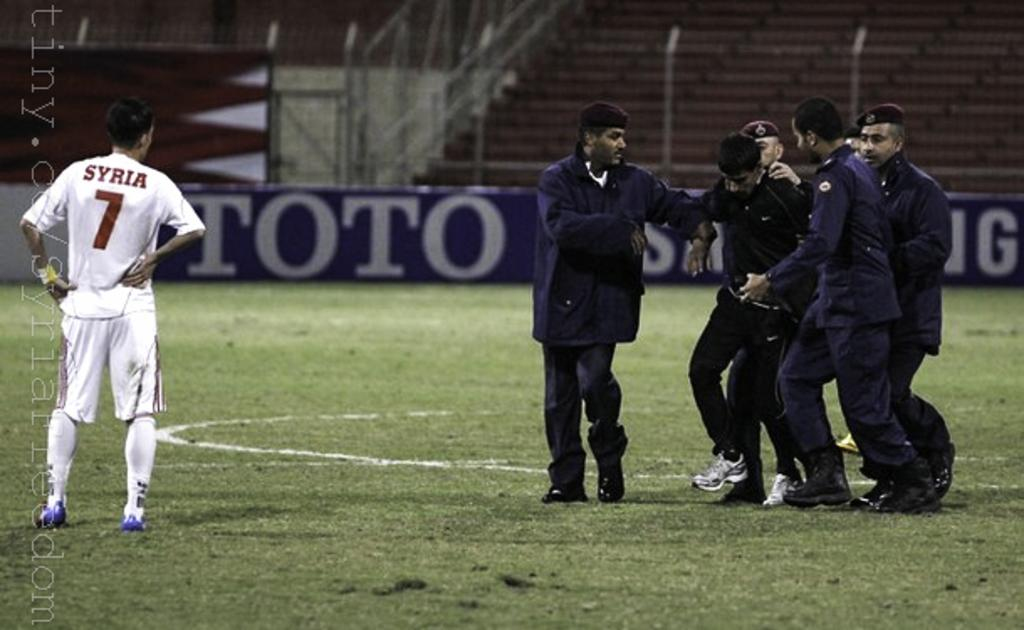<image>
Describe the image concisely. Soccer player wearing a white jersey with a number 7 on it standing on a field. 